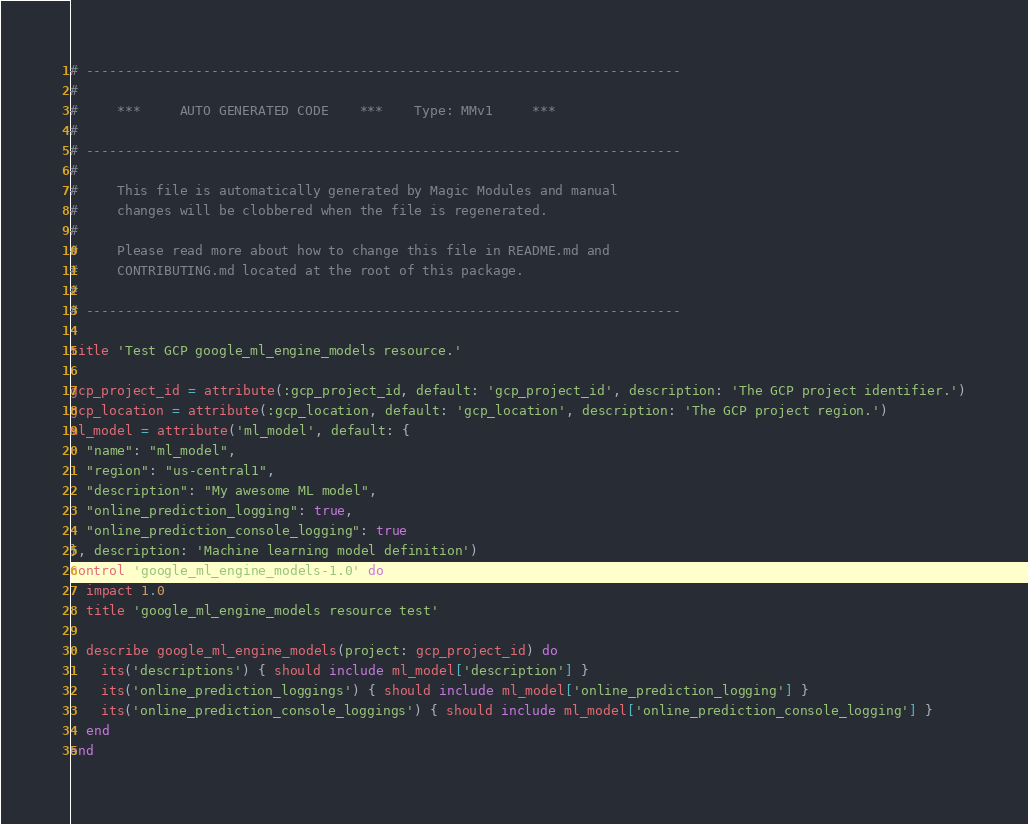Convert code to text. <code><loc_0><loc_0><loc_500><loc_500><_Ruby_># ----------------------------------------------------------------------------
#
#     ***     AUTO GENERATED CODE    ***    Type: MMv1     ***
#
# ----------------------------------------------------------------------------
#
#     This file is automatically generated by Magic Modules and manual
#     changes will be clobbered when the file is regenerated.
#
#     Please read more about how to change this file in README.md and
#     CONTRIBUTING.md located at the root of this package.
#
# ----------------------------------------------------------------------------

title 'Test GCP google_ml_engine_models resource.'

gcp_project_id = attribute(:gcp_project_id, default: 'gcp_project_id', description: 'The GCP project identifier.')
gcp_location = attribute(:gcp_location, default: 'gcp_location', description: 'The GCP project region.')
ml_model = attribute('ml_model', default: {
  "name": "ml_model",
  "region": "us-central1",
  "description": "My awesome ML model",
  "online_prediction_logging": true,
  "online_prediction_console_logging": true
}, description: 'Machine learning model definition')
control 'google_ml_engine_models-1.0' do
  impact 1.0
  title 'google_ml_engine_models resource test'

  describe google_ml_engine_models(project: gcp_project_id) do
    its('descriptions') { should include ml_model['description'] }
    its('online_prediction_loggings') { should include ml_model['online_prediction_logging'] }
    its('online_prediction_console_loggings') { should include ml_model['online_prediction_console_logging'] }
  end
end
</code> 